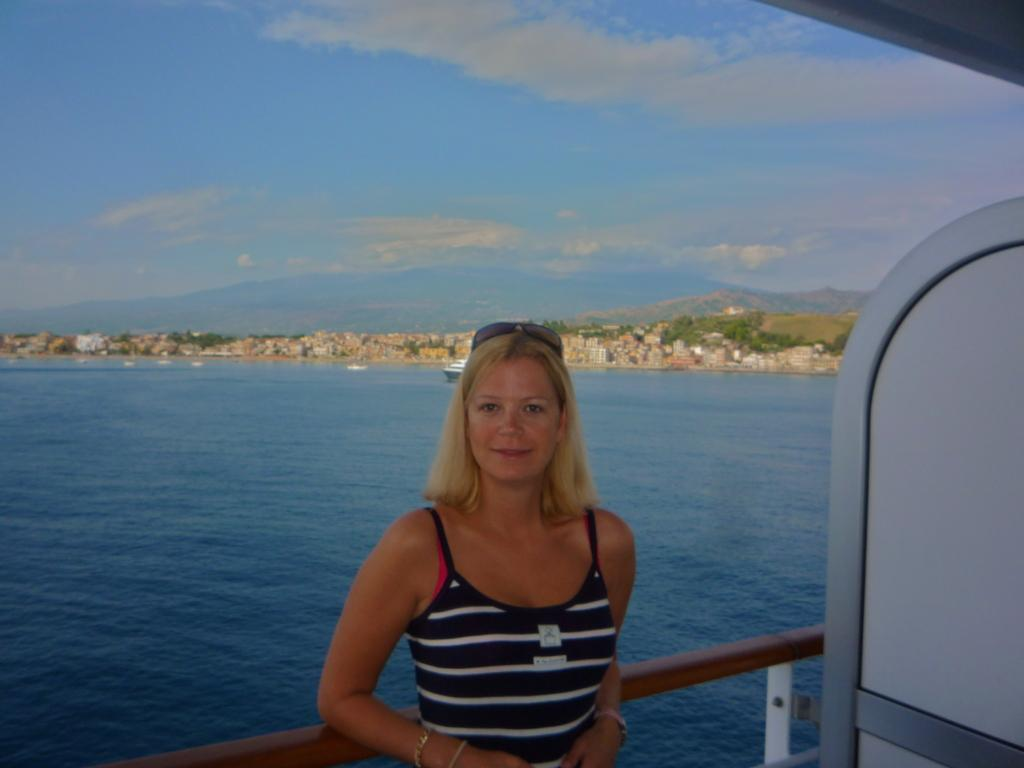Who is present in the image? There is a woman in the image. What is the woman's facial expression? The woman is smiling. Can you describe the objects in the image? The provided facts do not specify the objects in the image. What can be seen in the background of the image? There are buildings, trees, and the sky visible in the background of the image. What is the weather like in the image? The sky is visible with clouds present, suggesting a partly cloudy day. What nerve is the woman using to talk in the image? The image does not show the woman talking, nor does it provide information about her nerves. 